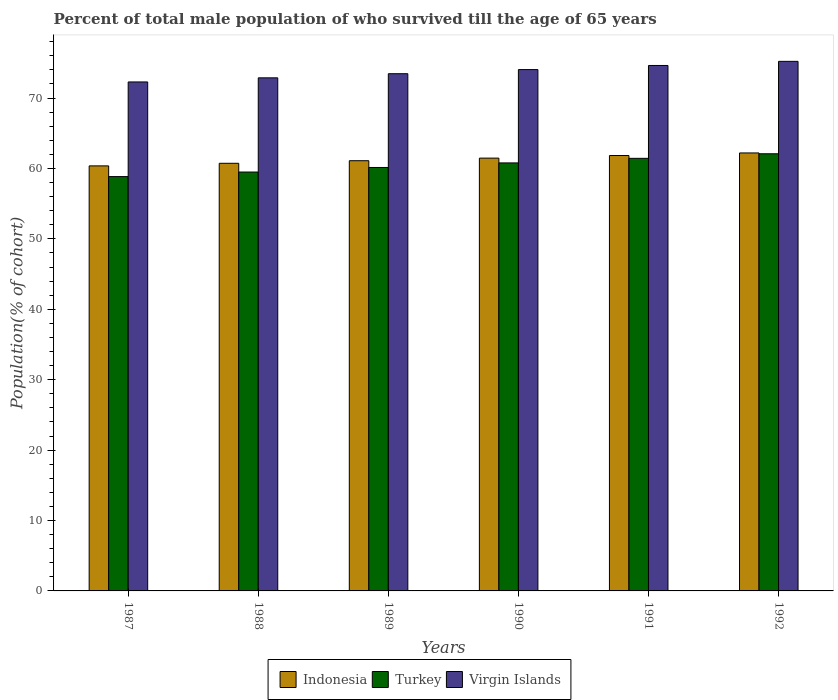Are the number of bars per tick equal to the number of legend labels?
Provide a short and direct response. Yes. In how many cases, is the number of bars for a given year not equal to the number of legend labels?
Offer a very short reply. 0. What is the percentage of total male population who survived till the age of 65 years in Indonesia in 1987?
Your answer should be compact. 60.37. Across all years, what is the maximum percentage of total male population who survived till the age of 65 years in Turkey?
Provide a short and direct response. 62.09. Across all years, what is the minimum percentage of total male population who survived till the age of 65 years in Indonesia?
Make the answer very short. 60.37. In which year was the percentage of total male population who survived till the age of 65 years in Virgin Islands minimum?
Ensure brevity in your answer.  1987. What is the total percentage of total male population who survived till the age of 65 years in Virgin Islands in the graph?
Offer a very short reply. 442.5. What is the difference between the percentage of total male population who survived till the age of 65 years in Indonesia in 1989 and that in 1992?
Give a very brief answer. -1.1. What is the difference between the percentage of total male population who survived till the age of 65 years in Virgin Islands in 1987 and the percentage of total male population who survived till the age of 65 years in Turkey in 1991?
Provide a short and direct response. 10.85. What is the average percentage of total male population who survived till the age of 65 years in Turkey per year?
Provide a succinct answer. 60.47. In the year 1991, what is the difference between the percentage of total male population who survived till the age of 65 years in Turkey and percentage of total male population who survived till the age of 65 years in Virgin Islands?
Ensure brevity in your answer.  -13.19. In how many years, is the percentage of total male population who survived till the age of 65 years in Virgin Islands greater than 32 %?
Provide a short and direct response. 6. What is the ratio of the percentage of total male population who survived till the age of 65 years in Indonesia in 1990 to that in 1992?
Make the answer very short. 0.99. Is the percentage of total male population who survived till the age of 65 years in Virgin Islands in 1989 less than that in 1991?
Your answer should be compact. Yes. Is the difference between the percentage of total male population who survived till the age of 65 years in Turkey in 1990 and 1992 greater than the difference between the percentage of total male population who survived till the age of 65 years in Virgin Islands in 1990 and 1992?
Offer a very short reply. No. What is the difference between the highest and the second highest percentage of total male population who survived till the age of 65 years in Turkey?
Keep it short and to the point. 0.65. What is the difference between the highest and the lowest percentage of total male population who survived till the age of 65 years in Virgin Islands?
Your answer should be compact. 2.93. Is the sum of the percentage of total male population who survived till the age of 65 years in Turkey in 1990 and 1991 greater than the maximum percentage of total male population who survived till the age of 65 years in Virgin Islands across all years?
Make the answer very short. Yes. What does the 3rd bar from the right in 1989 represents?
Offer a terse response. Indonesia. Is it the case that in every year, the sum of the percentage of total male population who survived till the age of 65 years in Turkey and percentage of total male population who survived till the age of 65 years in Indonesia is greater than the percentage of total male population who survived till the age of 65 years in Virgin Islands?
Your answer should be compact. Yes. What is the difference between two consecutive major ticks on the Y-axis?
Provide a short and direct response. 10. Are the values on the major ticks of Y-axis written in scientific E-notation?
Provide a short and direct response. No. Does the graph contain any zero values?
Provide a short and direct response. No. Does the graph contain grids?
Ensure brevity in your answer.  No. How many legend labels are there?
Keep it short and to the point. 3. What is the title of the graph?
Offer a terse response. Percent of total male population of who survived till the age of 65 years. Does "Latin America(all income levels)" appear as one of the legend labels in the graph?
Ensure brevity in your answer.  No. What is the label or title of the Y-axis?
Your answer should be very brief. Population(% of cohort). What is the Population(% of cohort) of Indonesia in 1987?
Keep it short and to the point. 60.37. What is the Population(% of cohort) of Turkey in 1987?
Your answer should be compact. 58.84. What is the Population(% of cohort) of Virgin Islands in 1987?
Make the answer very short. 72.29. What is the Population(% of cohort) of Indonesia in 1988?
Provide a succinct answer. 60.74. What is the Population(% of cohort) in Turkey in 1988?
Keep it short and to the point. 59.49. What is the Population(% of cohort) in Virgin Islands in 1988?
Offer a terse response. 72.87. What is the Population(% of cohort) of Indonesia in 1989?
Provide a short and direct response. 61.1. What is the Population(% of cohort) in Turkey in 1989?
Ensure brevity in your answer.  60.14. What is the Population(% of cohort) of Virgin Islands in 1989?
Your answer should be very brief. 73.46. What is the Population(% of cohort) of Indonesia in 1990?
Keep it short and to the point. 61.47. What is the Population(% of cohort) in Turkey in 1990?
Keep it short and to the point. 60.79. What is the Population(% of cohort) of Virgin Islands in 1990?
Provide a short and direct response. 74.04. What is the Population(% of cohort) in Indonesia in 1991?
Ensure brevity in your answer.  61.84. What is the Population(% of cohort) of Turkey in 1991?
Your answer should be very brief. 61.44. What is the Population(% of cohort) of Virgin Islands in 1991?
Offer a terse response. 74.63. What is the Population(% of cohort) in Indonesia in 1992?
Keep it short and to the point. 62.21. What is the Population(% of cohort) of Turkey in 1992?
Your answer should be very brief. 62.09. What is the Population(% of cohort) in Virgin Islands in 1992?
Your response must be concise. 75.21. Across all years, what is the maximum Population(% of cohort) of Indonesia?
Ensure brevity in your answer.  62.21. Across all years, what is the maximum Population(% of cohort) of Turkey?
Provide a succinct answer. 62.09. Across all years, what is the maximum Population(% of cohort) in Virgin Islands?
Provide a succinct answer. 75.21. Across all years, what is the minimum Population(% of cohort) of Indonesia?
Ensure brevity in your answer.  60.37. Across all years, what is the minimum Population(% of cohort) in Turkey?
Keep it short and to the point. 58.84. Across all years, what is the minimum Population(% of cohort) in Virgin Islands?
Provide a succinct answer. 72.29. What is the total Population(% of cohort) of Indonesia in the graph?
Keep it short and to the point. 367.72. What is the total Population(% of cohort) in Turkey in the graph?
Provide a short and direct response. 362.79. What is the total Population(% of cohort) of Virgin Islands in the graph?
Provide a short and direct response. 442.5. What is the difference between the Population(% of cohort) of Indonesia in 1987 and that in 1988?
Give a very brief answer. -0.37. What is the difference between the Population(% of cohort) in Turkey in 1987 and that in 1988?
Your response must be concise. -0.65. What is the difference between the Population(% of cohort) in Virgin Islands in 1987 and that in 1988?
Make the answer very short. -0.59. What is the difference between the Population(% of cohort) of Indonesia in 1987 and that in 1989?
Provide a short and direct response. -0.74. What is the difference between the Population(% of cohort) in Turkey in 1987 and that in 1989?
Ensure brevity in your answer.  -1.3. What is the difference between the Population(% of cohort) of Virgin Islands in 1987 and that in 1989?
Your answer should be compact. -1.17. What is the difference between the Population(% of cohort) in Indonesia in 1987 and that in 1990?
Make the answer very short. -1.1. What is the difference between the Population(% of cohort) in Turkey in 1987 and that in 1990?
Your answer should be very brief. -1.95. What is the difference between the Population(% of cohort) of Virgin Islands in 1987 and that in 1990?
Your answer should be compact. -1.76. What is the difference between the Population(% of cohort) in Indonesia in 1987 and that in 1991?
Your response must be concise. -1.47. What is the difference between the Population(% of cohort) in Turkey in 1987 and that in 1991?
Offer a very short reply. -2.59. What is the difference between the Population(% of cohort) of Virgin Islands in 1987 and that in 1991?
Offer a terse response. -2.34. What is the difference between the Population(% of cohort) in Indonesia in 1987 and that in 1992?
Your response must be concise. -1.84. What is the difference between the Population(% of cohort) of Turkey in 1987 and that in 1992?
Provide a succinct answer. -3.24. What is the difference between the Population(% of cohort) in Virgin Islands in 1987 and that in 1992?
Ensure brevity in your answer.  -2.93. What is the difference between the Population(% of cohort) of Indonesia in 1988 and that in 1989?
Make the answer very short. -0.37. What is the difference between the Population(% of cohort) of Turkey in 1988 and that in 1989?
Give a very brief answer. -0.65. What is the difference between the Population(% of cohort) of Virgin Islands in 1988 and that in 1989?
Your answer should be very brief. -0.59. What is the difference between the Population(% of cohort) in Indonesia in 1988 and that in 1990?
Offer a very short reply. -0.74. What is the difference between the Population(% of cohort) of Turkey in 1988 and that in 1990?
Your response must be concise. -1.3. What is the difference between the Population(% of cohort) in Virgin Islands in 1988 and that in 1990?
Your answer should be very brief. -1.17. What is the difference between the Population(% of cohort) of Indonesia in 1988 and that in 1991?
Provide a short and direct response. -1.1. What is the difference between the Population(% of cohort) of Turkey in 1988 and that in 1991?
Give a very brief answer. -1.95. What is the difference between the Population(% of cohort) in Virgin Islands in 1988 and that in 1991?
Your response must be concise. -1.76. What is the difference between the Population(% of cohort) in Indonesia in 1988 and that in 1992?
Ensure brevity in your answer.  -1.47. What is the difference between the Population(% of cohort) of Turkey in 1988 and that in 1992?
Your answer should be compact. -2.59. What is the difference between the Population(% of cohort) in Virgin Islands in 1988 and that in 1992?
Offer a terse response. -2.34. What is the difference between the Population(% of cohort) of Indonesia in 1989 and that in 1990?
Provide a short and direct response. -0.37. What is the difference between the Population(% of cohort) of Turkey in 1989 and that in 1990?
Keep it short and to the point. -0.65. What is the difference between the Population(% of cohort) of Virgin Islands in 1989 and that in 1990?
Your answer should be compact. -0.59. What is the difference between the Population(% of cohort) of Indonesia in 1989 and that in 1991?
Offer a terse response. -0.74. What is the difference between the Population(% of cohort) of Turkey in 1989 and that in 1991?
Offer a very short reply. -1.3. What is the difference between the Population(% of cohort) of Virgin Islands in 1989 and that in 1991?
Provide a short and direct response. -1.17. What is the difference between the Population(% of cohort) of Indonesia in 1989 and that in 1992?
Provide a succinct answer. -1.1. What is the difference between the Population(% of cohort) of Turkey in 1989 and that in 1992?
Give a very brief answer. -1.95. What is the difference between the Population(% of cohort) in Virgin Islands in 1989 and that in 1992?
Provide a succinct answer. -1.76. What is the difference between the Population(% of cohort) in Indonesia in 1990 and that in 1991?
Ensure brevity in your answer.  -0.37. What is the difference between the Population(% of cohort) of Turkey in 1990 and that in 1991?
Your answer should be very brief. -0.65. What is the difference between the Population(% of cohort) of Virgin Islands in 1990 and that in 1991?
Ensure brevity in your answer.  -0.59. What is the difference between the Population(% of cohort) of Indonesia in 1990 and that in 1992?
Give a very brief answer. -0.74. What is the difference between the Population(% of cohort) of Turkey in 1990 and that in 1992?
Make the answer very short. -1.3. What is the difference between the Population(% of cohort) of Virgin Islands in 1990 and that in 1992?
Ensure brevity in your answer.  -1.17. What is the difference between the Population(% of cohort) of Indonesia in 1991 and that in 1992?
Offer a terse response. -0.37. What is the difference between the Population(% of cohort) in Turkey in 1991 and that in 1992?
Offer a terse response. -0.65. What is the difference between the Population(% of cohort) of Virgin Islands in 1991 and that in 1992?
Offer a very short reply. -0.59. What is the difference between the Population(% of cohort) in Indonesia in 1987 and the Population(% of cohort) in Turkey in 1988?
Your answer should be compact. 0.87. What is the difference between the Population(% of cohort) in Indonesia in 1987 and the Population(% of cohort) in Virgin Islands in 1988?
Offer a terse response. -12.51. What is the difference between the Population(% of cohort) of Turkey in 1987 and the Population(% of cohort) of Virgin Islands in 1988?
Keep it short and to the point. -14.03. What is the difference between the Population(% of cohort) in Indonesia in 1987 and the Population(% of cohort) in Turkey in 1989?
Give a very brief answer. 0.23. What is the difference between the Population(% of cohort) of Indonesia in 1987 and the Population(% of cohort) of Virgin Islands in 1989?
Offer a terse response. -13.09. What is the difference between the Population(% of cohort) in Turkey in 1987 and the Population(% of cohort) in Virgin Islands in 1989?
Offer a terse response. -14.61. What is the difference between the Population(% of cohort) of Indonesia in 1987 and the Population(% of cohort) of Turkey in 1990?
Ensure brevity in your answer.  -0.42. What is the difference between the Population(% of cohort) in Indonesia in 1987 and the Population(% of cohort) in Virgin Islands in 1990?
Keep it short and to the point. -13.68. What is the difference between the Population(% of cohort) in Turkey in 1987 and the Population(% of cohort) in Virgin Islands in 1990?
Your answer should be compact. -15.2. What is the difference between the Population(% of cohort) of Indonesia in 1987 and the Population(% of cohort) of Turkey in 1991?
Offer a very short reply. -1.07. What is the difference between the Population(% of cohort) of Indonesia in 1987 and the Population(% of cohort) of Virgin Islands in 1991?
Your response must be concise. -14.26. What is the difference between the Population(% of cohort) of Turkey in 1987 and the Population(% of cohort) of Virgin Islands in 1991?
Provide a short and direct response. -15.78. What is the difference between the Population(% of cohort) in Indonesia in 1987 and the Population(% of cohort) in Turkey in 1992?
Keep it short and to the point. -1.72. What is the difference between the Population(% of cohort) in Indonesia in 1987 and the Population(% of cohort) in Virgin Islands in 1992?
Offer a terse response. -14.85. What is the difference between the Population(% of cohort) of Turkey in 1987 and the Population(% of cohort) of Virgin Islands in 1992?
Your answer should be compact. -16.37. What is the difference between the Population(% of cohort) of Indonesia in 1988 and the Population(% of cohort) of Turkey in 1989?
Give a very brief answer. 0.59. What is the difference between the Population(% of cohort) in Indonesia in 1988 and the Population(% of cohort) in Virgin Islands in 1989?
Make the answer very short. -12.72. What is the difference between the Population(% of cohort) of Turkey in 1988 and the Population(% of cohort) of Virgin Islands in 1989?
Offer a very short reply. -13.96. What is the difference between the Population(% of cohort) in Indonesia in 1988 and the Population(% of cohort) in Turkey in 1990?
Ensure brevity in your answer.  -0.05. What is the difference between the Population(% of cohort) of Indonesia in 1988 and the Population(% of cohort) of Virgin Islands in 1990?
Keep it short and to the point. -13.31. What is the difference between the Population(% of cohort) in Turkey in 1988 and the Population(% of cohort) in Virgin Islands in 1990?
Your answer should be compact. -14.55. What is the difference between the Population(% of cohort) of Indonesia in 1988 and the Population(% of cohort) of Turkey in 1991?
Keep it short and to the point. -0.7. What is the difference between the Population(% of cohort) in Indonesia in 1988 and the Population(% of cohort) in Virgin Islands in 1991?
Provide a succinct answer. -13.89. What is the difference between the Population(% of cohort) in Turkey in 1988 and the Population(% of cohort) in Virgin Islands in 1991?
Your answer should be very brief. -15.14. What is the difference between the Population(% of cohort) of Indonesia in 1988 and the Population(% of cohort) of Turkey in 1992?
Provide a short and direct response. -1.35. What is the difference between the Population(% of cohort) in Indonesia in 1988 and the Population(% of cohort) in Virgin Islands in 1992?
Your answer should be compact. -14.48. What is the difference between the Population(% of cohort) of Turkey in 1988 and the Population(% of cohort) of Virgin Islands in 1992?
Offer a very short reply. -15.72. What is the difference between the Population(% of cohort) of Indonesia in 1989 and the Population(% of cohort) of Turkey in 1990?
Provide a short and direct response. 0.31. What is the difference between the Population(% of cohort) in Indonesia in 1989 and the Population(% of cohort) in Virgin Islands in 1990?
Keep it short and to the point. -12.94. What is the difference between the Population(% of cohort) in Turkey in 1989 and the Population(% of cohort) in Virgin Islands in 1990?
Offer a terse response. -13.9. What is the difference between the Population(% of cohort) in Indonesia in 1989 and the Population(% of cohort) in Turkey in 1991?
Your answer should be compact. -0.34. What is the difference between the Population(% of cohort) in Indonesia in 1989 and the Population(% of cohort) in Virgin Islands in 1991?
Offer a terse response. -13.53. What is the difference between the Population(% of cohort) in Turkey in 1989 and the Population(% of cohort) in Virgin Islands in 1991?
Your response must be concise. -14.49. What is the difference between the Population(% of cohort) in Indonesia in 1989 and the Population(% of cohort) in Turkey in 1992?
Your answer should be very brief. -0.98. What is the difference between the Population(% of cohort) in Indonesia in 1989 and the Population(% of cohort) in Virgin Islands in 1992?
Give a very brief answer. -14.11. What is the difference between the Population(% of cohort) of Turkey in 1989 and the Population(% of cohort) of Virgin Islands in 1992?
Provide a short and direct response. -15.07. What is the difference between the Population(% of cohort) in Indonesia in 1990 and the Population(% of cohort) in Turkey in 1991?
Keep it short and to the point. 0.03. What is the difference between the Population(% of cohort) in Indonesia in 1990 and the Population(% of cohort) in Virgin Islands in 1991?
Your answer should be compact. -13.16. What is the difference between the Population(% of cohort) in Turkey in 1990 and the Population(% of cohort) in Virgin Islands in 1991?
Your answer should be very brief. -13.84. What is the difference between the Population(% of cohort) in Indonesia in 1990 and the Population(% of cohort) in Turkey in 1992?
Provide a succinct answer. -0.62. What is the difference between the Population(% of cohort) in Indonesia in 1990 and the Population(% of cohort) in Virgin Islands in 1992?
Give a very brief answer. -13.74. What is the difference between the Population(% of cohort) in Turkey in 1990 and the Population(% of cohort) in Virgin Islands in 1992?
Offer a terse response. -14.42. What is the difference between the Population(% of cohort) of Indonesia in 1991 and the Population(% of cohort) of Turkey in 1992?
Provide a succinct answer. -0.25. What is the difference between the Population(% of cohort) of Indonesia in 1991 and the Population(% of cohort) of Virgin Islands in 1992?
Provide a succinct answer. -13.38. What is the difference between the Population(% of cohort) in Turkey in 1991 and the Population(% of cohort) in Virgin Islands in 1992?
Make the answer very short. -13.78. What is the average Population(% of cohort) of Indonesia per year?
Your response must be concise. 61.29. What is the average Population(% of cohort) in Turkey per year?
Give a very brief answer. 60.47. What is the average Population(% of cohort) in Virgin Islands per year?
Your answer should be compact. 73.75. In the year 1987, what is the difference between the Population(% of cohort) in Indonesia and Population(% of cohort) in Turkey?
Keep it short and to the point. 1.52. In the year 1987, what is the difference between the Population(% of cohort) of Indonesia and Population(% of cohort) of Virgin Islands?
Your answer should be compact. -11.92. In the year 1987, what is the difference between the Population(% of cohort) of Turkey and Population(% of cohort) of Virgin Islands?
Ensure brevity in your answer.  -13.44. In the year 1988, what is the difference between the Population(% of cohort) in Indonesia and Population(% of cohort) in Turkey?
Provide a short and direct response. 1.24. In the year 1988, what is the difference between the Population(% of cohort) of Indonesia and Population(% of cohort) of Virgin Islands?
Offer a terse response. -12.14. In the year 1988, what is the difference between the Population(% of cohort) in Turkey and Population(% of cohort) in Virgin Islands?
Provide a short and direct response. -13.38. In the year 1989, what is the difference between the Population(% of cohort) of Indonesia and Population(% of cohort) of Turkey?
Offer a very short reply. 0.96. In the year 1989, what is the difference between the Population(% of cohort) in Indonesia and Population(% of cohort) in Virgin Islands?
Give a very brief answer. -12.36. In the year 1989, what is the difference between the Population(% of cohort) of Turkey and Population(% of cohort) of Virgin Islands?
Give a very brief answer. -13.32. In the year 1990, what is the difference between the Population(% of cohort) in Indonesia and Population(% of cohort) in Turkey?
Your answer should be compact. 0.68. In the year 1990, what is the difference between the Population(% of cohort) in Indonesia and Population(% of cohort) in Virgin Islands?
Your answer should be very brief. -12.57. In the year 1990, what is the difference between the Population(% of cohort) in Turkey and Population(% of cohort) in Virgin Islands?
Ensure brevity in your answer.  -13.25. In the year 1991, what is the difference between the Population(% of cohort) of Indonesia and Population(% of cohort) of Turkey?
Make the answer very short. 0.4. In the year 1991, what is the difference between the Population(% of cohort) of Indonesia and Population(% of cohort) of Virgin Islands?
Offer a very short reply. -12.79. In the year 1991, what is the difference between the Population(% of cohort) of Turkey and Population(% of cohort) of Virgin Islands?
Your answer should be very brief. -13.19. In the year 1992, what is the difference between the Population(% of cohort) of Indonesia and Population(% of cohort) of Turkey?
Your response must be concise. 0.12. In the year 1992, what is the difference between the Population(% of cohort) of Indonesia and Population(% of cohort) of Virgin Islands?
Make the answer very short. -13.01. In the year 1992, what is the difference between the Population(% of cohort) of Turkey and Population(% of cohort) of Virgin Islands?
Offer a very short reply. -13.13. What is the ratio of the Population(% of cohort) of Indonesia in 1987 to that in 1988?
Your answer should be very brief. 0.99. What is the ratio of the Population(% of cohort) in Virgin Islands in 1987 to that in 1988?
Give a very brief answer. 0.99. What is the ratio of the Population(% of cohort) of Turkey in 1987 to that in 1989?
Your response must be concise. 0.98. What is the ratio of the Population(% of cohort) of Virgin Islands in 1987 to that in 1989?
Make the answer very short. 0.98. What is the ratio of the Population(% of cohort) of Indonesia in 1987 to that in 1990?
Your answer should be compact. 0.98. What is the ratio of the Population(% of cohort) of Turkey in 1987 to that in 1990?
Your answer should be compact. 0.97. What is the ratio of the Population(% of cohort) in Virgin Islands in 1987 to that in 1990?
Give a very brief answer. 0.98. What is the ratio of the Population(% of cohort) in Indonesia in 1987 to that in 1991?
Provide a succinct answer. 0.98. What is the ratio of the Population(% of cohort) in Turkey in 1987 to that in 1991?
Your answer should be very brief. 0.96. What is the ratio of the Population(% of cohort) in Virgin Islands in 1987 to that in 1991?
Offer a terse response. 0.97. What is the ratio of the Population(% of cohort) in Indonesia in 1987 to that in 1992?
Make the answer very short. 0.97. What is the ratio of the Population(% of cohort) of Turkey in 1987 to that in 1992?
Make the answer very short. 0.95. What is the ratio of the Population(% of cohort) in Virgin Islands in 1987 to that in 1992?
Ensure brevity in your answer.  0.96. What is the ratio of the Population(% of cohort) of Turkey in 1988 to that in 1989?
Offer a terse response. 0.99. What is the ratio of the Population(% of cohort) of Turkey in 1988 to that in 1990?
Provide a short and direct response. 0.98. What is the ratio of the Population(% of cohort) of Virgin Islands in 1988 to that in 1990?
Provide a succinct answer. 0.98. What is the ratio of the Population(% of cohort) of Indonesia in 1988 to that in 1991?
Give a very brief answer. 0.98. What is the ratio of the Population(% of cohort) of Turkey in 1988 to that in 1991?
Provide a succinct answer. 0.97. What is the ratio of the Population(% of cohort) of Virgin Islands in 1988 to that in 1991?
Offer a very short reply. 0.98. What is the ratio of the Population(% of cohort) of Indonesia in 1988 to that in 1992?
Offer a very short reply. 0.98. What is the ratio of the Population(% of cohort) of Turkey in 1988 to that in 1992?
Provide a succinct answer. 0.96. What is the ratio of the Population(% of cohort) in Virgin Islands in 1988 to that in 1992?
Give a very brief answer. 0.97. What is the ratio of the Population(% of cohort) of Indonesia in 1989 to that in 1990?
Offer a terse response. 0.99. What is the ratio of the Population(% of cohort) of Turkey in 1989 to that in 1990?
Ensure brevity in your answer.  0.99. What is the ratio of the Population(% of cohort) of Virgin Islands in 1989 to that in 1990?
Your response must be concise. 0.99. What is the ratio of the Population(% of cohort) in Indonesia in 1989 to that in 1991?
Provide a short and direct response. 0.99. What is the ratio of the Population(% of cohort) in Turkey in 1989 to that in 1991?
Offer a terse response. 0.98. What is the ratio of the Population(% of cohort) of Virgin Islands in 1989 to that in 1991?
Keep it short and to the point. 0.98. What is the ratio of the Population(% of cohort) of Indonesia in 1989 to that in 1992?
Offer a terse response. 0.98. What is the ratio of the Population(% of cohort) of Turkey in 1989 to that in 1992?
Your answer should be very brief. 0.97. What is the ratio of the Population(% of cohort) of Virgin Islands in 1989 to that in 1992?
Provide a short and direct response. 0.98. What is the ratio of the Population(% of cohort) of Turkey in 1990 to that in 1991?
Offer a terse response. 0.99. What is the ratio of the Population(% of cohort) in Indonesia in 1990 to that in 1992?
Offer a very short reply. 0.99. What is the ratio of the Population(% of cohort) of Turkey in 1990 to that in 1992?
Keep it short and to the point. 0.98. What is the ratio of the Population(% of cohort) of Virgin Islands in 1990 to that in 1992?
Provide a succinct answer. 0.98. What is the difference between the highest and the second highest Population(% of cohort) of Indonesia?
Keep it short and to the point. 0.37. What is the difference between the highest and the second highest Population(% of cohort) in Turkey?
Ensure brevity in your answer.  0.65. What is the difference between the highest and the second highest Population(% of cohort) of Virgin Islands?
Your answer should be compact. 0.59. What is the difference between the highest and the lowest Population(% of cohort) of Indonesia?
Your response must be concise. 1.84. What is the difference between the highest and the lowest Population(% of cohort) in Turkey?
Your answer should be very brief. 3.24. What is the difference between the highest and the lowest Population(% of cohort) of Virgin Islands?
Ensure brevity in your answer.  2.93. 